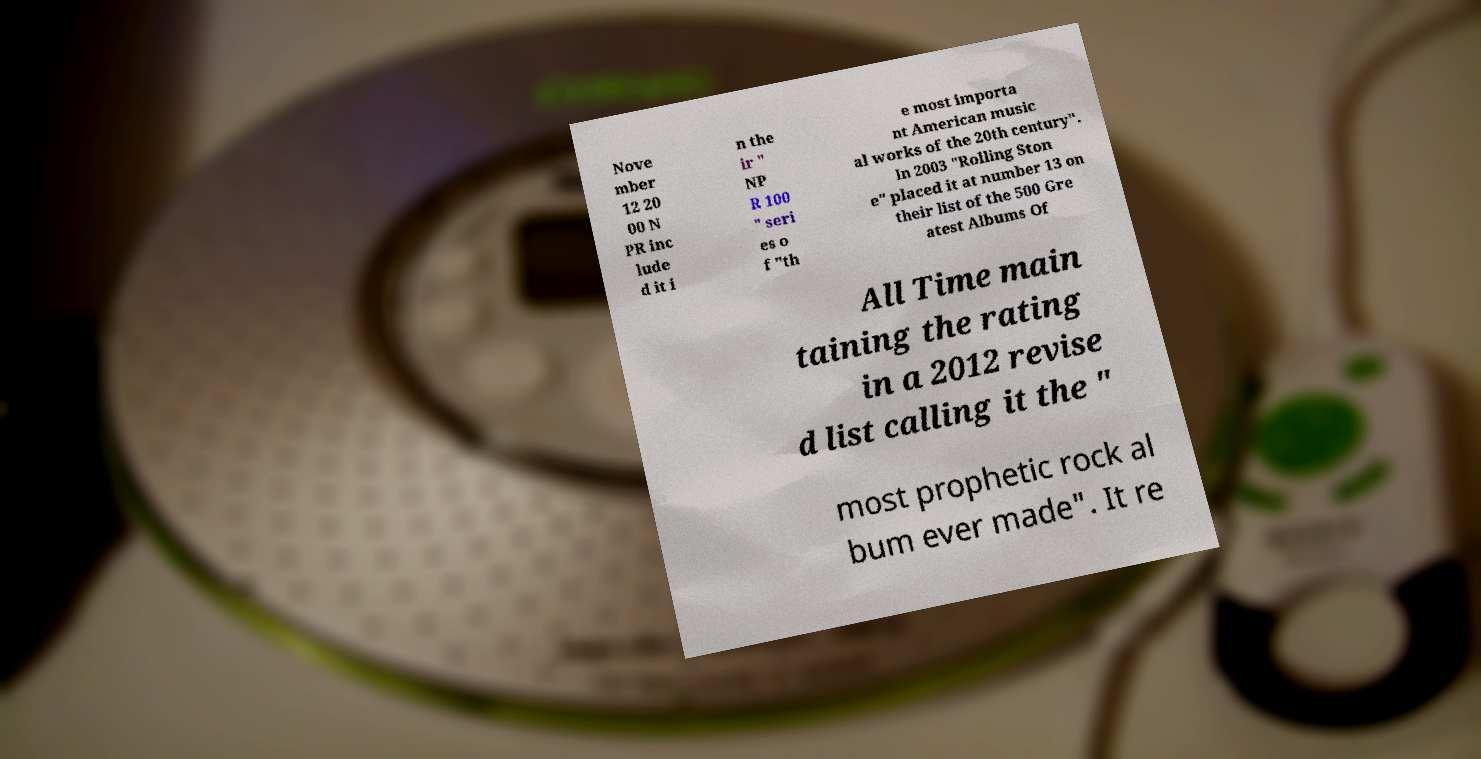Can you read and provide the text displayed in the image?This photo seems to have some interesting text. Can you extract and type it out for me? Nove mber 12 20 00 N PR inc lude d it i n the ir " NP R 100 " seri es o f "th e most importa nt American music al works of the 20th century". In 2003 "Rolling Ston e" placed it at number 13 on their list of the 500 Gre atest Albums Of All Time main taining the rating in a 2012 revise d list calling it the " most prophetic rock al bum ever made". It re 